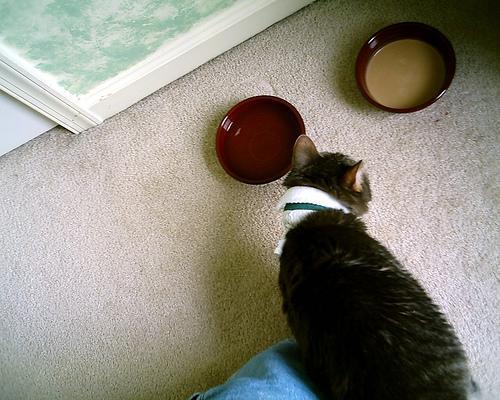How many dishes are for the cat?
Give a very brief answer. 2. How many bowls can you see?
Give a very brief answer. 2. How many giraffes are here?
Give a very brief answer. 0. 